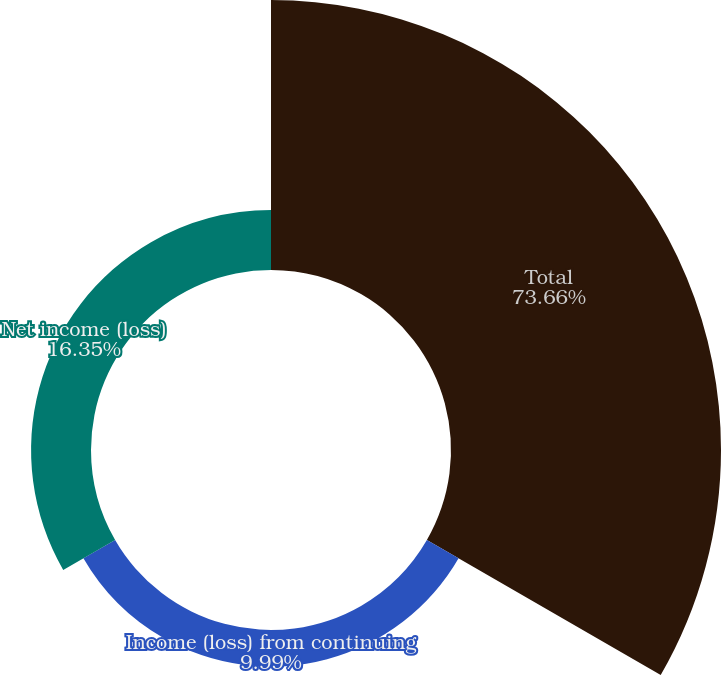<chart> <loc_0><loc_0><loc_500><loc_500><pie_chart><fcel>Total<fcel>Income (loss) from continuing<fcel>Net income (loss)<nl><fcel>73.66%<fcel>9.99%<fcel>16.35%<nl></chart> 